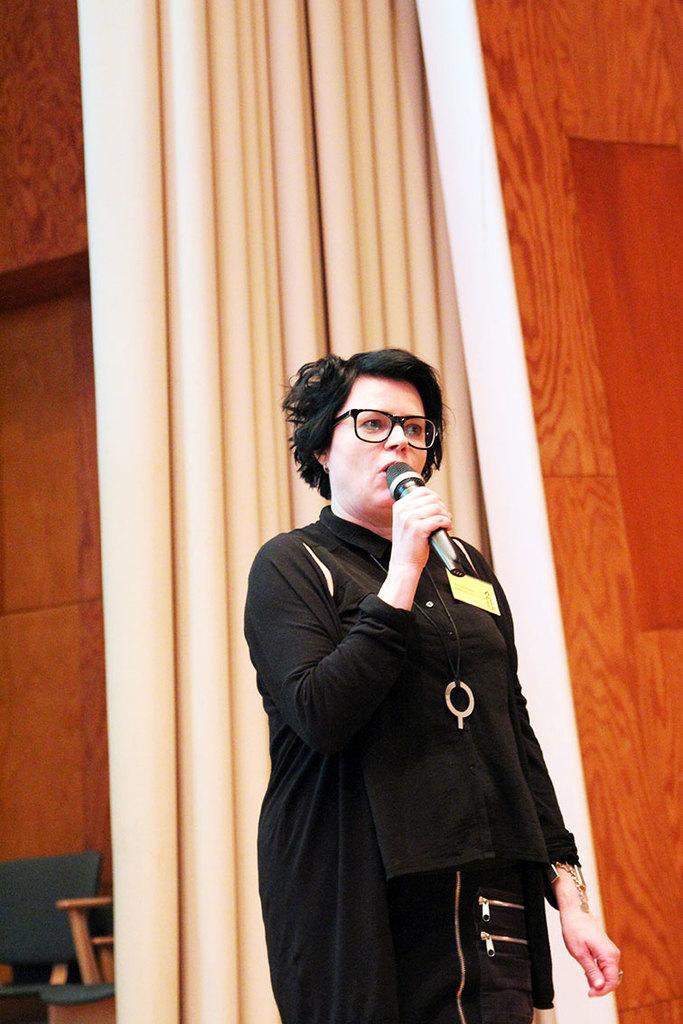Please provide a concise description of this image. The woman in the middle of the picture wearing a black dress is holding a microphone in his hand and she is talking on the microphone. Behind her, we see a curtain and a wall in brown color. In the left bottom of the picture, we see the empty chairs. 